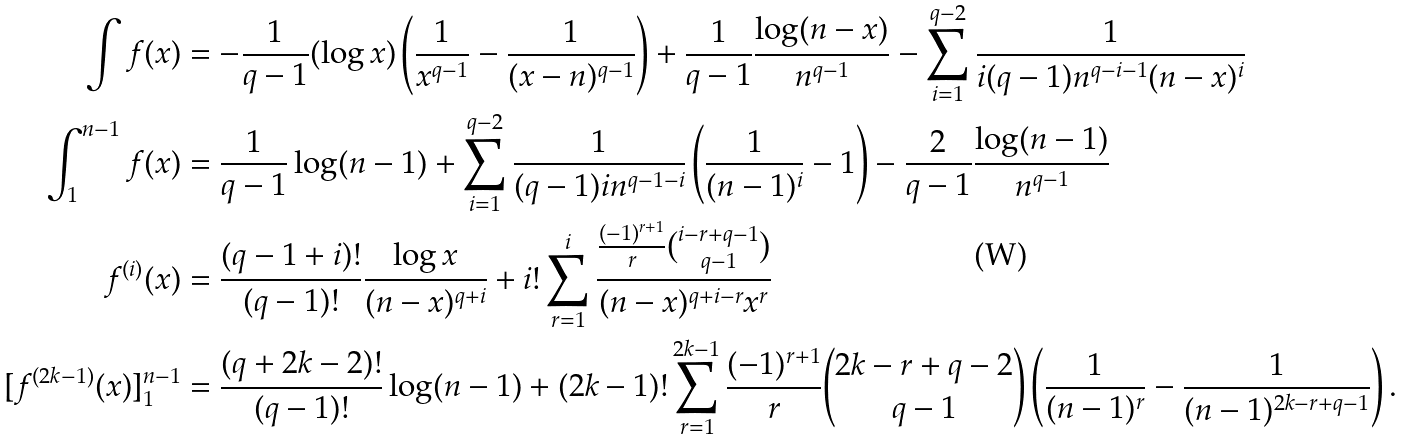Convert formula to latex. <formula><loc_0><loc_0><loc_500><loc_500>\int f ( x ) & = - \frac { 1 } { q - 1 } ( \log x ) \left ( \frac { 1 } { x ^ { q - 1 } } - \frac { 1 } { ( x - n ) ^ { q - 1 } } \right ) + \frac { 1 } { q - 1 } \frac { \log ( n - x ) } { n ^ { q - 1 } } - \sum _ { i = 1 } ^ { q - 2 } \frac { 1 } { i ( q - 1 ) n ^ { q - i - 1 } ( n - x ) ^ { i } } \\ \int _ { 1 } ^ { n - 1 } f ( x ) & = \frac { 1 } { q - 1 } \log ( n - 1 ) + \sum _ { i = 1 } ^ { q - 2 } \frac { 1 } { ( q - 1 ) i n ^ { q - 1 - i } } \left ( \frac { 1 } { ( n - 1 ) ^ { i } } - 1 \right ) - \frac { 2 } { q - 1 } \frac { \log ( n - 1 ) } { n ^ { q - 1 } } \\ f ^ { ( i ) } ( x ) & = \frac { ( q - 1 + i ) ! } { ( q - 1 ) ! } \frac { \log x } { ( n - x ) ^ { q + i } } + i ! \sum _ { r = 1 } ^ { i } \frac { \frac { ( - 1 ) ^ { r + 1 } } { r } \binom { i - r + q - 1 } { q - 1 } } { ( n - x ) ^ { q + i - r } x ^ { r } } \\ [ f ^ { ( 2 k - 1 ) } ( x ) ] ^ { n - 1 } _ { 1 } & = \frac { ( q + 2 k - 2 ) ! } { ( q - 1 ) ! } \log ( n - 1 ) + ( 2 k - 1 ) ! \sum _ { r = 1 } ^ { 2 k - 1 } \frac { ( - 1 ) ^ { r + 1 } } { r } \binom { 2 k - r + q - 2 } { q - 1 } \left ( \frac { 1 } { ( n - 1 ) ^ { r } } - \frac { 1 } { ( n - 1 ) ^ { 2 k - r + q - 1 } } \right ) .</formula> 